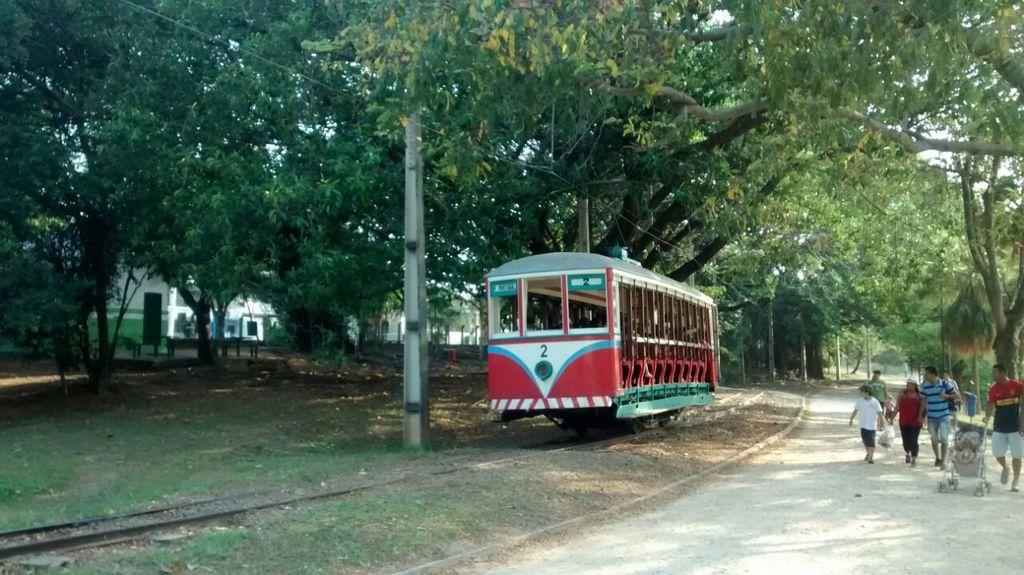How would you summarize this image in a sentence or two? In this picture we can see a train on a railway track, beside this train we can see people on the ground, here we can see a stroller, electric poles and some objects and in the background we can see buildings, trees and some objects. 